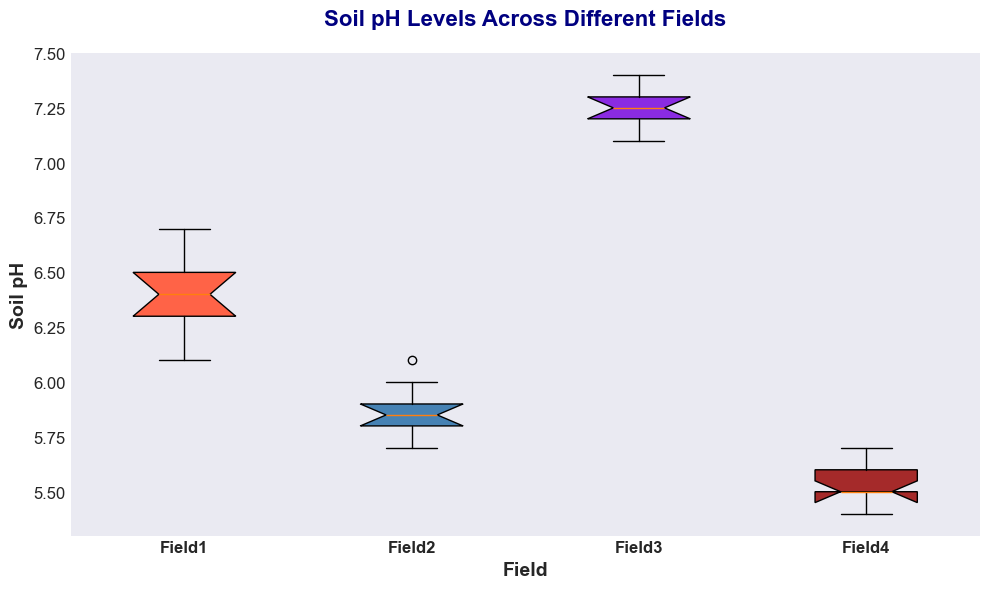What is the median Soil pH level of Field1? The median value is the middle number in the ordered list of Soil pH levels for Field1. Ordering the pH levels: 6.1, 6.2, 6.3, 6.3, 6.4, 6.4, 6.5, 6.5, 6.6, 6.7. The median value, the average of the two middle values (6.4 and 6.4), is 6.4.
Answer: 6.4 Which field has the highest variability in Soil pH levels? Variability in a box plot is often represented by the length of the boxes (interquartile range) and the presence of outliers. In the box plot, Field3 has the largest spread (distance) between the lower and upper quartiles, indicating the highest variability.
Answer: Field3 How does the median Soil pH level of Field4 compare to that of Field2? Look at the central line in each box plot to locate the median. For Field4, the median pH is 5.5. For Field2, the median pH is 5.8. Comparing these values, Field2 has a higher median pH level than Field4.
Answer: Field2 has a higher median Which field has the lowest minimum Soil pH level? The minimum value in a box plot is identified by the bottom whisker. Comparing all fields, Field4 has the lowest minimum Soil pH at around 5.4.
Answer: Field4 What are the lower and upper quartiles for Field2? The lower quartile (Q1) is the bottom edge of the box, and the upper quartile (Q3) is the top edge of the box. For Field2, Q1 is around 5.8, and Q3 is around 5.9.
Answer: Q1: 5.8, Q3: 5.9 Do any of the fields have outliers in their Soil pH levels? Outliers are typically represented by points outside the whiskers of the box plot. In this box plot, none of the fields have points that are separate from the whiskers, indicating no outliers.
Answer: No What is the range of Soil pH levels for Field3? The range is calculated by subtracting the minimum value from the maximum value. For Field3, the minimum Soil pH is about 7.1, and the maximum is about 7.4. The range is 7.4 - 7.1.
Answer: 0.3 Which field has the darkest color in the box plot? The visual attribute of color can be observed directly. Among all fields, Field4 has the darkest box color in the plot.
Answer: Field4 